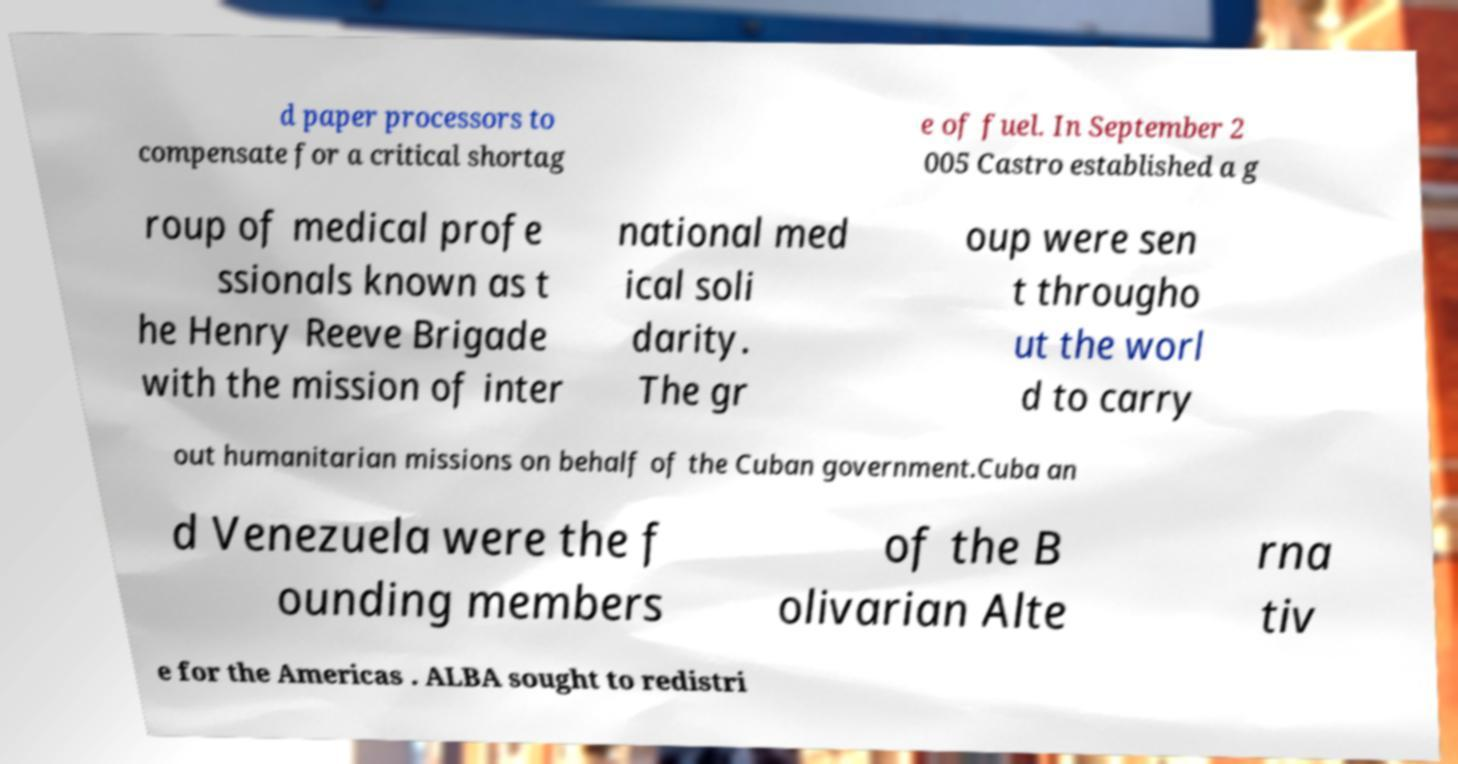For documentation purposes, I need the text within this image transcribed. Could you provide that? d paper processors to compensate for a critical shortag e of fuel. In September 2 005 Castro established a g roup of medical profe ssionals known as t he Henry Reeve Brigade with the mission of inter national med ical soli darity. The gr oup were sen t througho ut the worl d to carry out humanitarian missions on behalf of the Cuban government.Cuba an d Venezuela were the f ounding members of the B olivarian Alte rna tiv e for the Americas . ALBA sought to redistri 